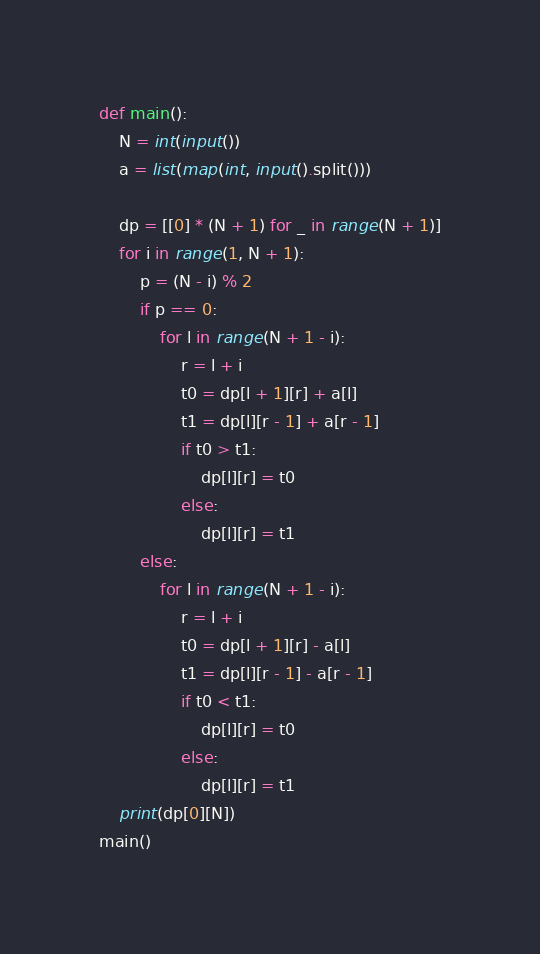<code> <loc_0><loc_0><loc_500><loc_500><_Python_>def main():
    N = int(input())
    a = list(map(int, input().split()))

    dp = [[0] * (N + 1) for _ in range(N + 1)]
    for i in range(1, N + 1):
        p = (N - i) % 2
        if p == 0:
            for l in range(N + 1 - i):
                r = l + i
                t0 = dp[l + 1][r] + a[l]
                t1 = dp[l][r - 1] + a[r - 1]
                if t0 > t1:
                    dp[l][r] = t0
                else:
                    dp[l][r] = t1
        else:
            for l in range(N + 1 - i):
                r = l + i
                t0 = dp[l + 1][r] - a[l]
                t1 = dp[l][r - 1] - a[r - 1]
                if t0 < t1:
                    dp[l][r] = t0
                else:
                    dp[l][r] = t1
    print(dp[0][N])
main()
</code> 